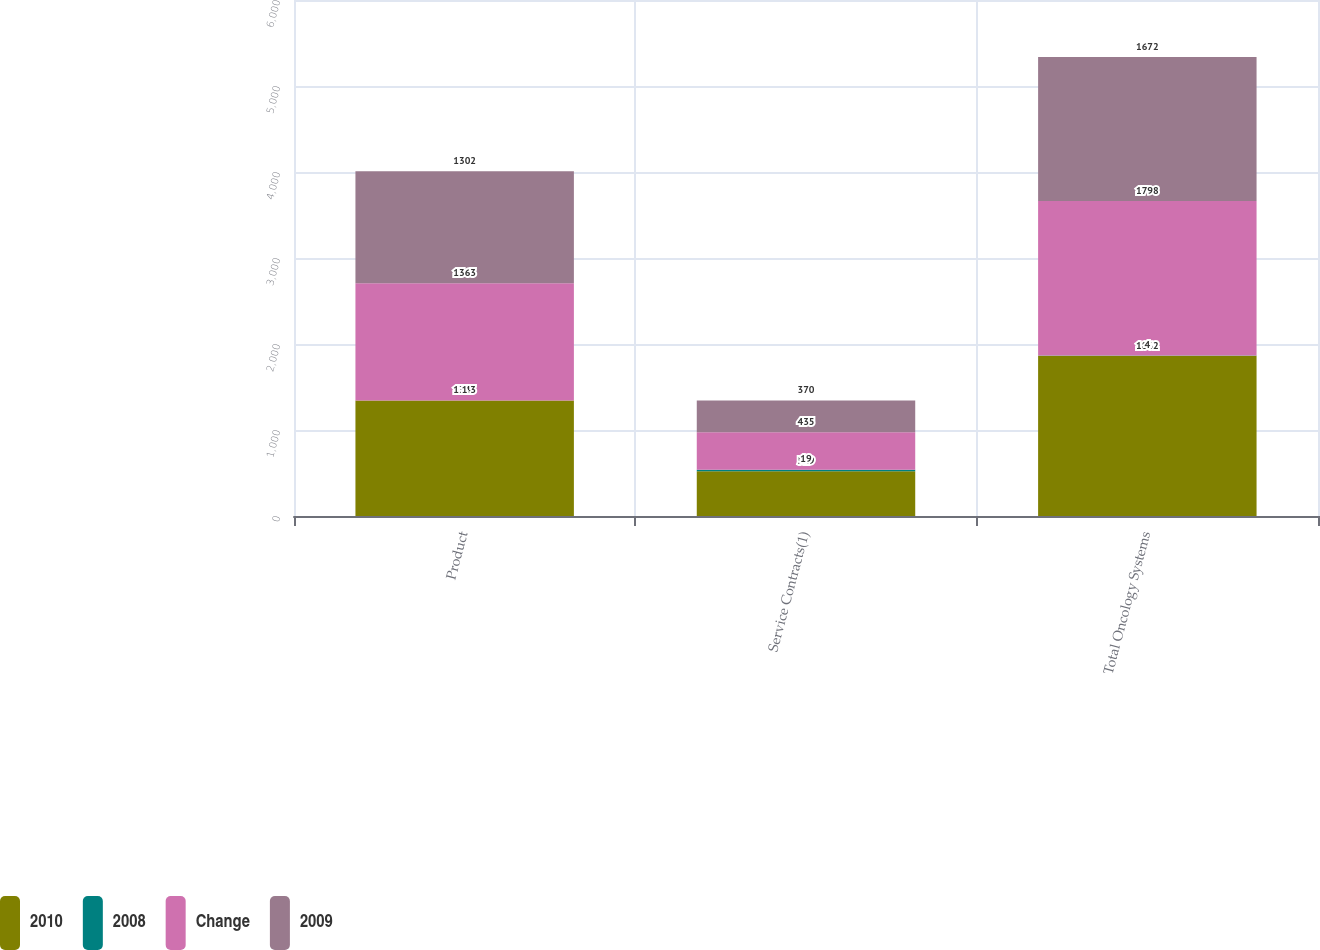Convert chart. <chart><loc_0><loc_0><loc_500><loc_500><stacked_bar_chart><ecel><fcel>Product<fcel>Service Contracts(1)<fcel>Total Oncology Systems<nl><fcel>2010<fcel>1343<fcel>519<fcel>1862<nl><fcel>2008<fcel>1<fcel>19<fcel>4<nl><fcel>Change<fcel>1363<fcel>435<fcel>1798<nl><fcel>2009<fcel>1302<fcel>370<fcel>1672<nl></chart> 